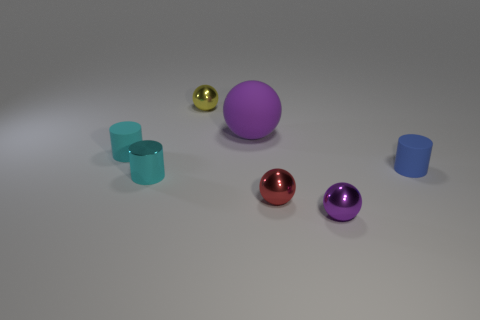Subtract all cyan shiny cylinders. How many cylinders are left? 2 Add 3 small red metal objects. How many objects exist? 10 Subtract all red spheres. How many spheres are left? 3 Subtract all yellow cylinders. Subtract all gray spheres. How many cylinders are left? 3 Subtract all cylinders. How many objects are left? 4 Subtract all tiny rubber things. Subtract all big purple metallic cylinders. How many objects are left? 5 Add 2 tiny shiny cylinders. How many tiny shiny cylinders are left? 3 Add 5 green blocks. How many green blocks exist? 5 Subtract 0 cyan spheres. How many objects are left? 7 